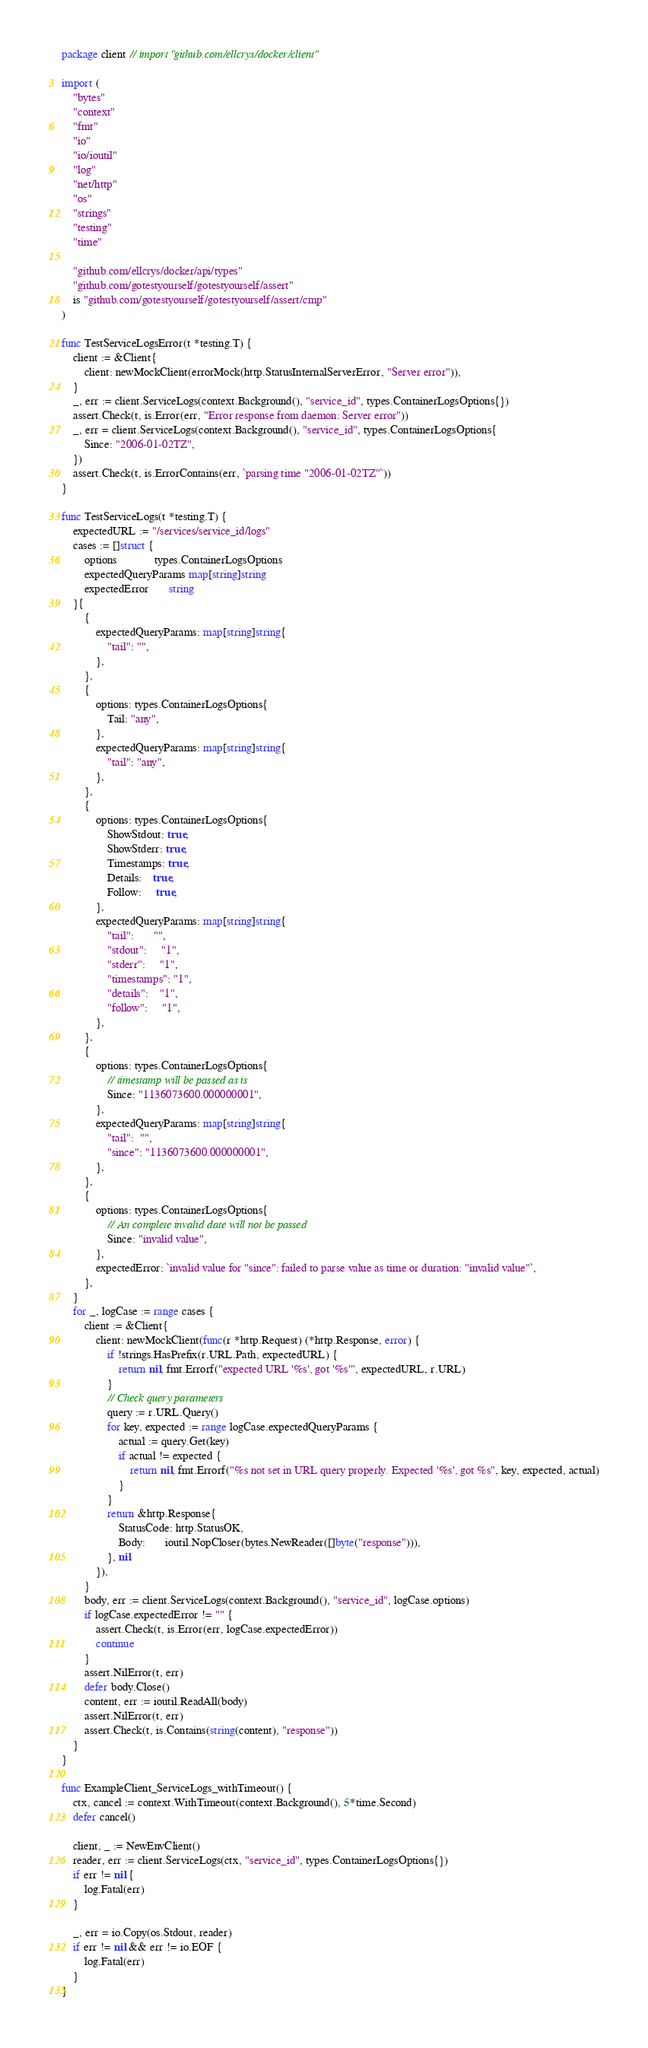<code> <loc_0><loc_0><loc_500><loc_500><_Go_>package client // import "github.com/ellcrys/docker/client"

import (
	"bytes"
	"context"
	"fmt"
	"io"
	"io/ioutil"
	"log"
	"net/http"
	"os"
	"strings"
	"testing"
	"time"

	"github.com/ellcrys/docker/api/types"
	"github.com/gotestyourself/gotestyourself/assert"
	is "github.com/gotestyourself/gotestyourself/assert/cmp"
)

func TestServiceLogsError(t *testing.T) {
	client := &Client{
		client: newMockClient(errorMock(http.StatusInternalServerError, "Server error")),
	}
	_, err := client.ServiceLogs(context.Background(), "service_id", types.ContainerLogsOptions{})
	assert.Check(t, is.Error(err, "Error response from daemon: Server error"))
	_, err = client.ServiceLogs(context.Background(), "service_id", types.ContainerLogsOptions{
		Since: "2006-01-02TZ",
	})
	assert.Check(t, is.ErrorContains(err, `parsing time "2006-01-02TZ"`))
}

func TestServiceLogs(t *testing.T) {
	expectedURL := "/services/service_id/logs"
	cases := []struct {
		options             types.ContainerLogsOptions
		expectedQueryParams map[string]string
		expectedError       string
	}{
		{
			expectedQueryParams: map[string]string{
				"tail": "",
			},
		},
		{
			options: types.ContainerLogsOptions{
				Tail: "any",
			},
			expectedQueryParams: map[string]string{
				"tail": "any",
			},
		},
		{
			options: types.ContainerLogsOptions{
				ShowStdout: true,
				ShowStderr: true,
				Timestamps: true,
				Details:    true,
				Follow:     true,
			},
			expectedQueryParams: map[string]string{
				"tail":       "",
				"stdout":     "1",
				"stderr":     "1",
				"timestamps": "1",
				"details":    "1",
				"follow":     "1",
			},
		},
		{
			options: types.ContainerLogsOptions{
				// timestamp will be passed as is
				Since: "1136073600.000000001",
			},
			expectedQueryParams: map[string]string{
				"tail":  "",
				"since": "1136073600.000000001",
			},
		},
		{
			options: types.ContainerLogsOptions{
				// An complete invalid date will not be passed
				Since: "invalid value",
			},
			expectedError: `invalid value for "since": failed to parse value as time or duration: "invalid value"`,
		},
	}
	for _, logCase := range cases {
		client := &Client{
			client: newMockClient(func(r *http.Request) (*http.Response, error) {
				if !strings.HasPrefix(r.URL.Path, expectedURL) {
					return nil, fmt.Errorf("expected URL '%s', got '%s'", expectedURL, r.URL)
				}
				// Check query parameters
				query := r.URL.Query()
				for key, expected := range logCase.expectedQueryParams {
					actual := query.Get(key)
					if actual != expected {
						return nil, fmt.Errorf("%s not set in URL query properly. Expected '%s', got %s", key, expected, actual)
					}
				}
				return &http.Response{
					StatusCode: http.StatusOK,
					Body:       ioutil.NopCloser(bytes.NewReader([]byte("response"))),
				}, nil
			}),
		}
		body, err := client.ServiceLogs(context.Background(), "service_id", logCase.options)
		if logCase.expectedError != "" {
			assert.Check(t, is.Error(err, logCase.expectedError))
			continue
		}
		assert.NilError(t, err)
		defer body.Close()
		content, err := ioutil.ReadAll(body)
		assert.NilError(t, err)
		assert.Check(t, is.Contains(string(content), "response"))
	}
}

func ExampleClient_ServiceLogs_withTimeout() {
	ctx, cancel := context.WithTimeout(context.Background(), 5*time.Second)
	defer cancel()

	client, _ := NewEnvClient()
	reader, err := client.ServiceLogs(ctx, "service_id", types.ContainerLogsOptions{})
	if err != nil {
		log.Fatal(err)
	}

	_, err = io.Copy(os.Stdout, reader)
	if err != nil && err != io.EOF {
		log.Fatal(err)
	}
}
</code> 